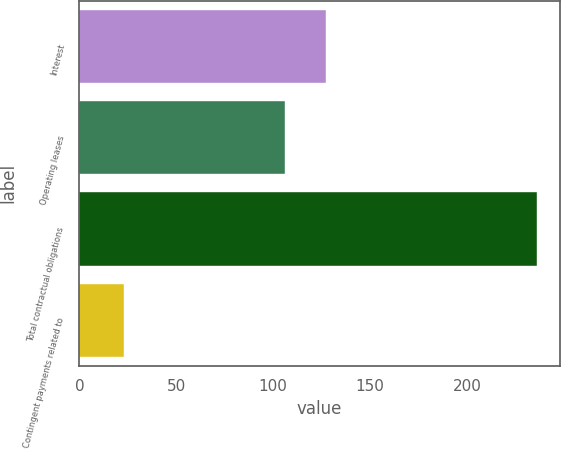<chart> <loc_0><loc_0><loc_500><loc_500><bar_chart><fcel>Interest<fcel>Operating leases<fcel>Total contractual obligations<fcel>Contingent payments related to<nl><fcel>127.3<fcel>106<fcel>236<fcel>23<nl></chart> 